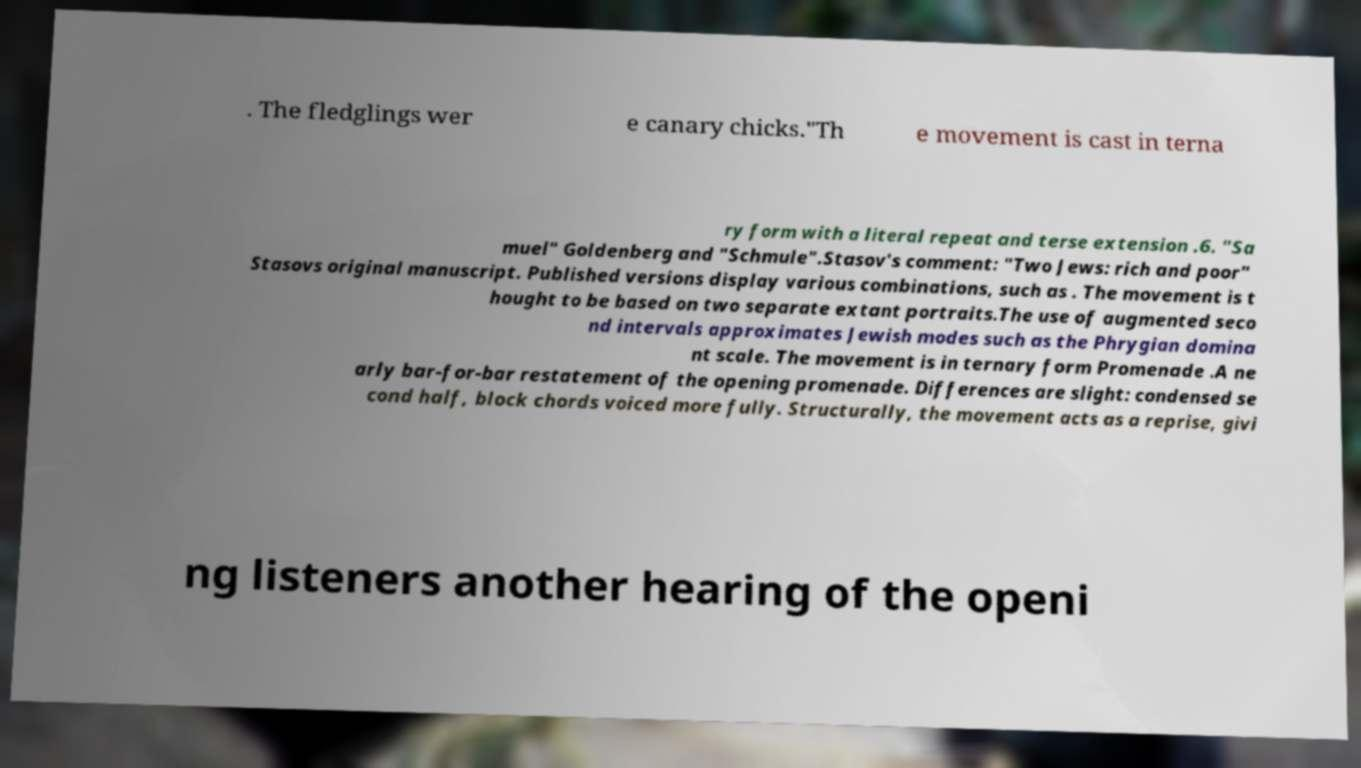Can you read and provide the text displayed in the image?This photo seems to have some interesting text. Can you extract and type it out for me? . The fledglings wer e canary chicks."Th e movement is cast in terna ry form with a literal repeat and terse extension .6. "Sa muel" Goldenberg and "Schmule".Stasov's comment: "Two Jews: rich and poor" Stasovs original manuscript. Published versions display various combinations, such as . The movement is t hought to be based on two separate extant portraits.The use of augmented seco nd intervals approximates Jewish modes such as the Phrygian domina nt scale. The movement is in ternary form Promenade .A ne arly bar-for-bar restatement of the opening promenade. Differences are slight: condensed se cond half, block chords voiced more fully. Structurally, the movement acts as a reprise, givi ng listeners another hearing of the openi 